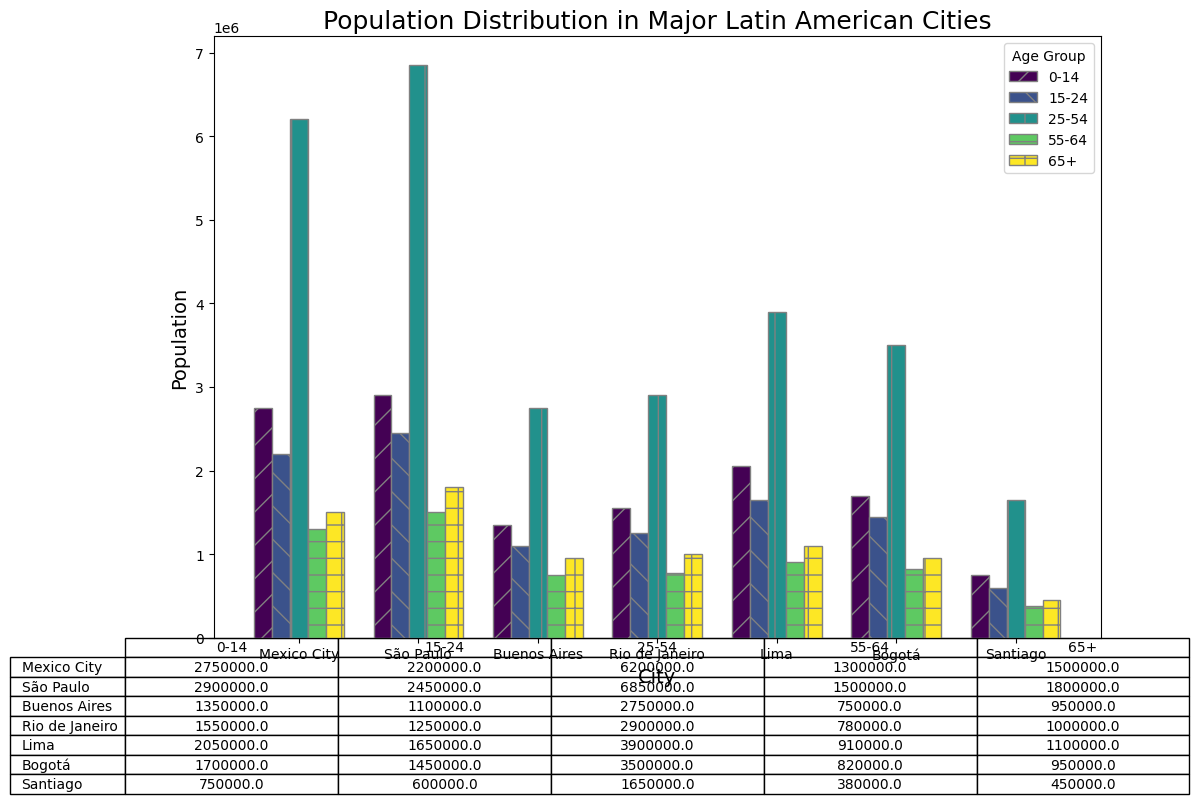Which city has the largest population in the 25-54 age group? From the plot, compare the heights of the bars corresponding to the 25-54 age group for all cities. São Paulo's bar is the tallest.
Answer: São Paulo Which age group has the smallest population in Santiago? Check the bar heights for Santiago across all age groups. The 0-14 age group has the shortest bar.
Answer: 0-14 What is the total population for Lima across all age groups? Add up the population for all age groups in Lima: 2,050,000 + 1,650,000 + 3,900,000 + 910,000 + 1,100,000.
Answer: 9,610,000 Which city has a higher population of people aged 65+, Buenos Aires or Bogotá? Compare the bar heights for the 65+ age group for Buenos Aires and Bogotá. Buenos Aires has a taller bar.
Answer: Buenos Aires What is the difference in the population size of the 0-14 age group between São Paulo and Rio de Janeiro? Subtract the population of the 0-14 age group in Rio de Janeiro from that in São Paulo: 2,900,000 - 1,550,000.
Answer: 1,350,000 Which age group in Mexico City has nearly double the population size of Buenos Aires in the same age group? Compare the population data for each age group between Mexico City and Buenos Aires. The 25-54 age group in Mexico City (6,200,000) is almost double that of Buenos Aires (2,750,000).
Answer: 25-54 How does the population of the 15-24 age group in Mexico City compare to that in Lima? Compare the bar heights for the 15-24 age group between Mexico City and Lima. The bars are nearly the same height, so their populations are very close.
Answer: Almost equal Which city has the smallest population in the 55-64 age group? Check the bar heights for the 55-64 age group for all cities. Santiago has the shortest bar.
Answer: Santiago What is the average population of the 0-14 age group across all cities? Calculate the average by summing the populations for the 0-14 age group in all cities and dividing by the number of cities: (2,750,000 + 2,900,000 + 1,350,000 + 1,550,000 + 2,050,000 + 1,700,000 + 750,000) / 7.
Answer: 1,864,286 